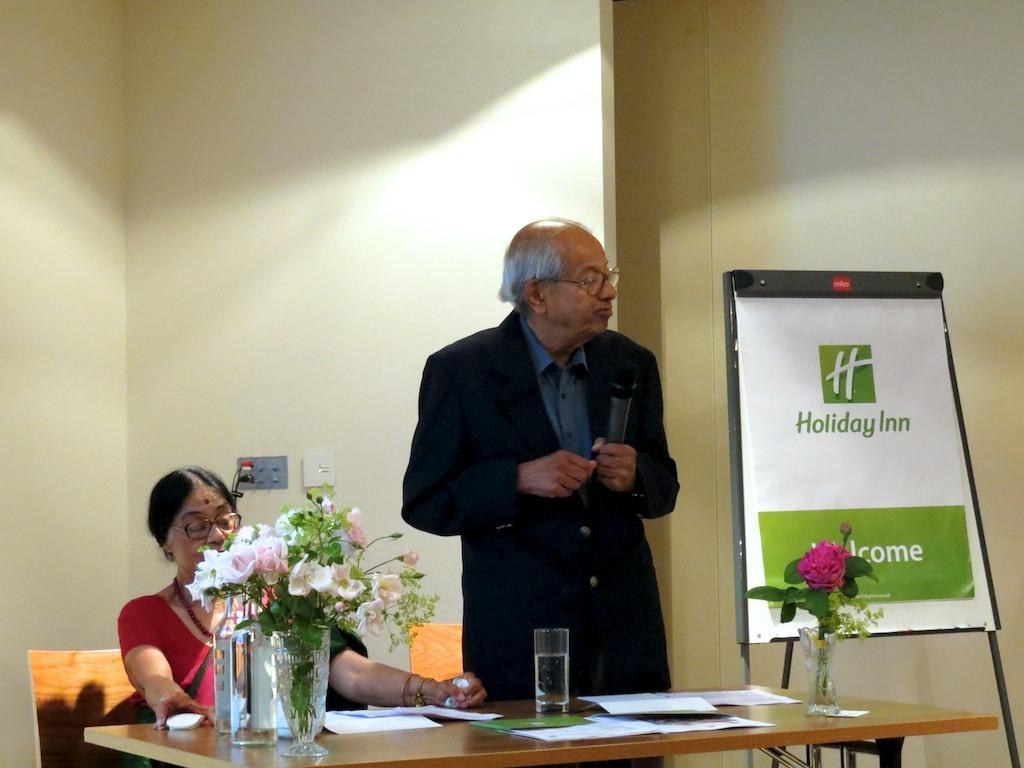Please provide a concise description of this image. This picture describes about two people, in the left side of the given image a woman is seated on the chair, in the middle of the image a man is standing and he is holding a microphone in his hands, in front of them we can see books, gases, flower vase on the table besides to him we can see a hoarding. 